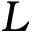<formula> <loc_0><loc_0><loc_500><loc_500>L</formula> 